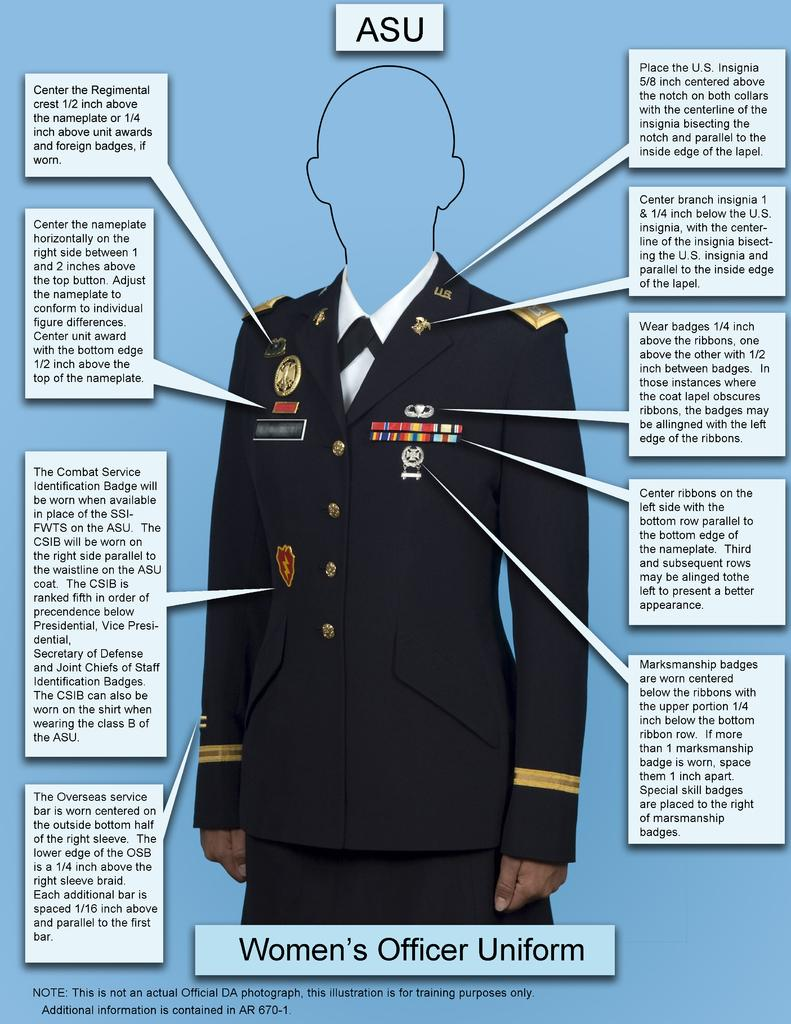What type of visual content is the image? The image is a poster. What can be found on the poster? The poster contains comments. Is there any clothing item featured in the image? Yes, there is a uniform in the image. What additional details can be observed about the uniform? The uniform has badges. Can you see any waves in the image? There are no waves present in the image; it features a poster with comments and a uniform. What type of joke is being told in the image? There is no joke present in the image; it contains comments and a uniform with badges. 